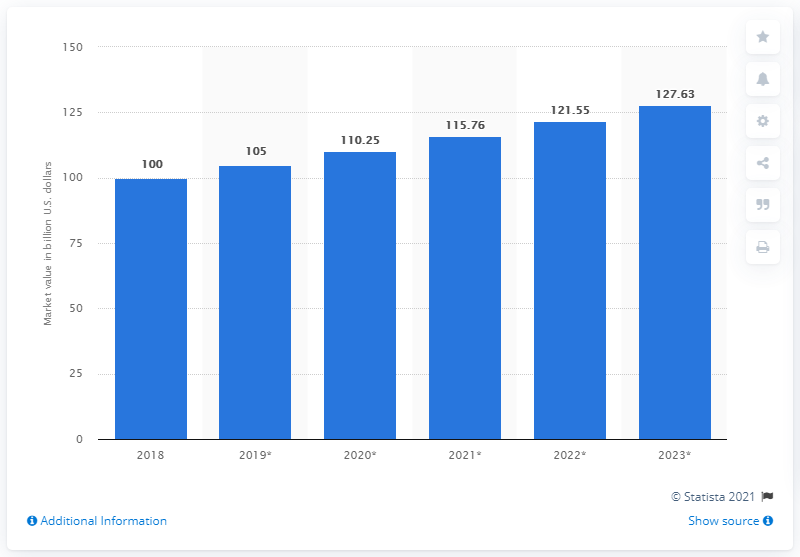Point out several critical features in this image. The global jeanswear market is forecasted to reach a value of 127.63 billion USD by 2023. According to estimates, the global jeanswear market was valued at approximately 100 billion dollars in 2018. 